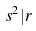<formula> <loc_0><loc_0><loc_500><loc_500>s ^ { 2 } | r</formula> 